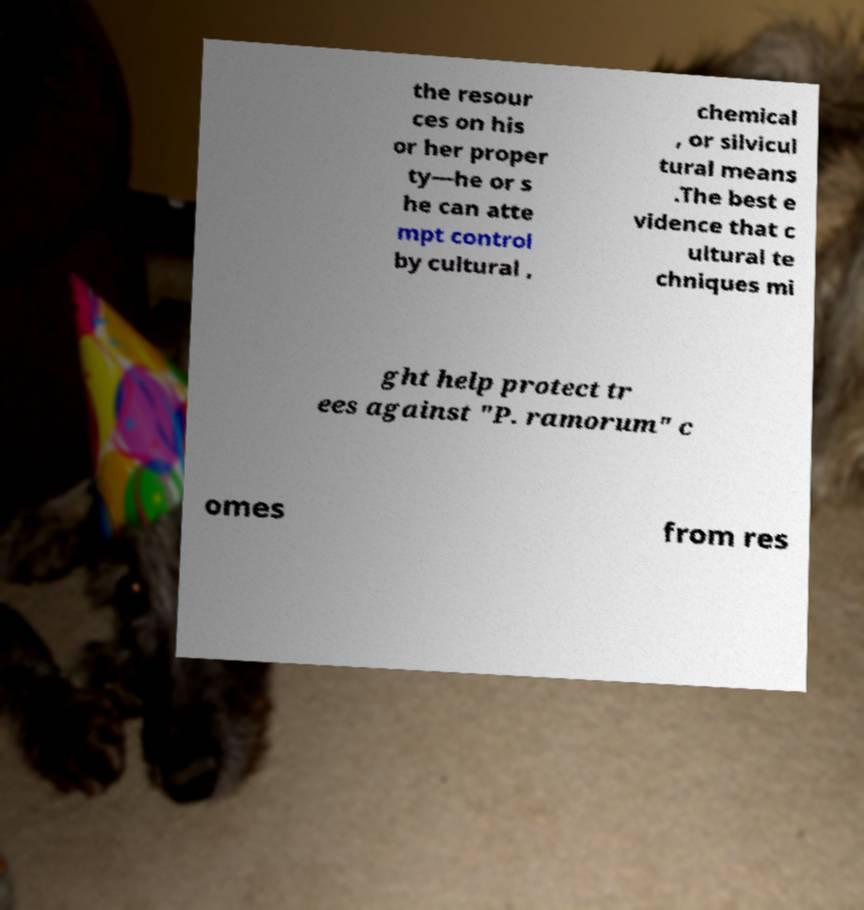Please read and relay the text visible in this image. What does it say? the resour ces on his or her proper ty—he or s he can atte mpt control by cultural , chemical , or silvicul tural means .The best e vidence that c ultural te chniques mi ght help protect tr ees against "P. ramorum" c omes from res 